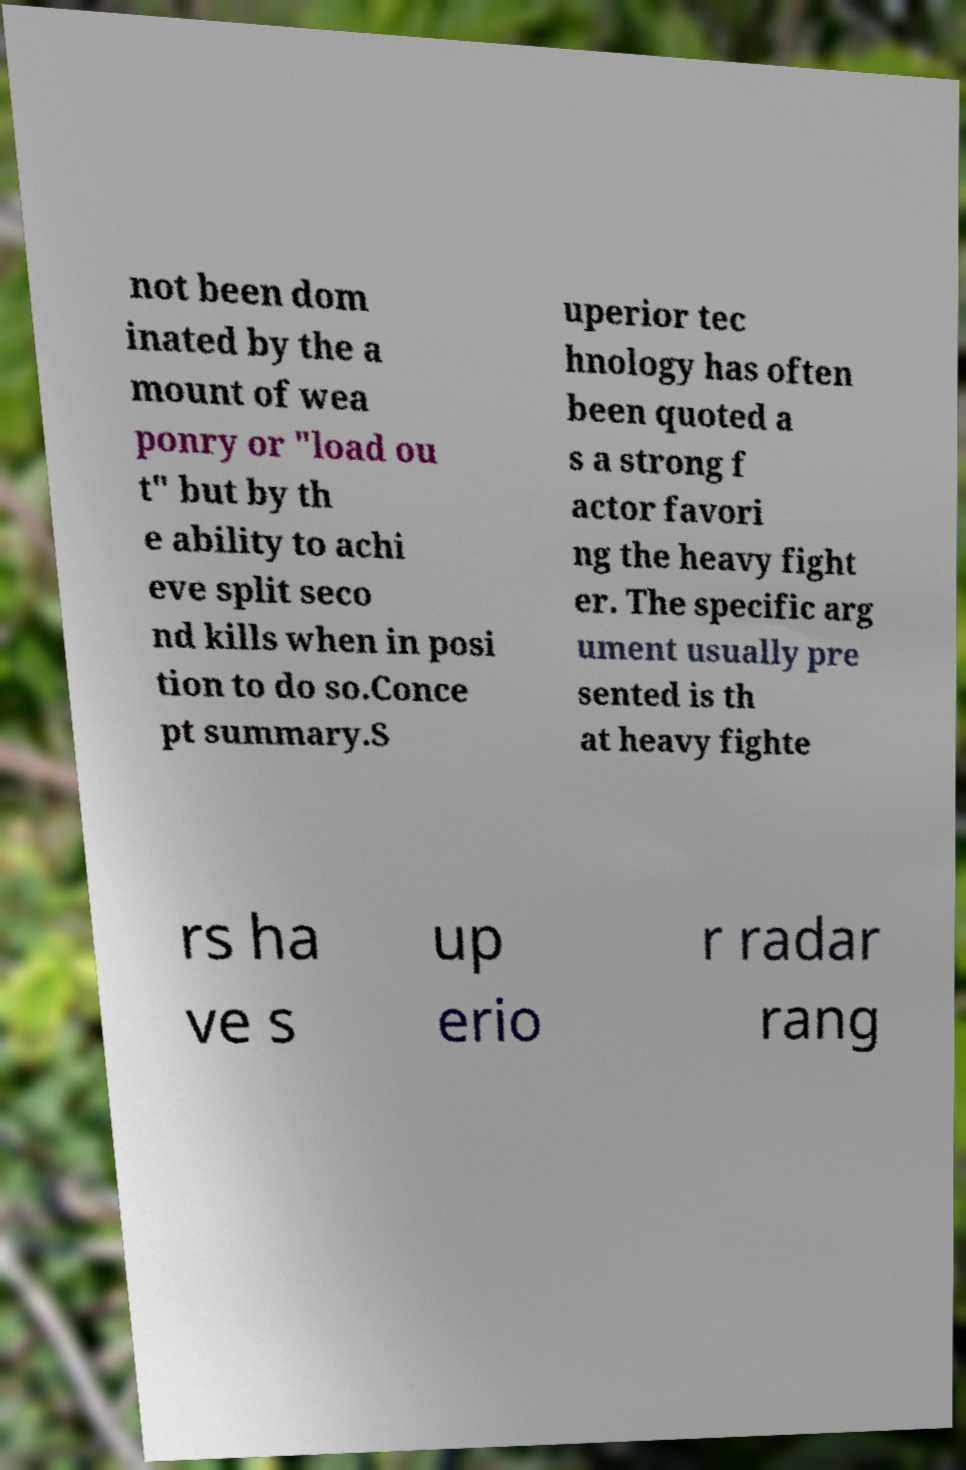Please read and relay the text visible in this image. What does it say? not been dom inated by the a mount of wea ponry or "load ou t" but by th e ability to achi eve split seco nd kills when in posi tion to do so.Conce pt summary.S uperior tec hnology has often been quoted a s a strong f actor favori ng the heavy fight er. The specific arg ument usually pre sented is th at heavy fighte rs ha ve s up erio r radar rang 